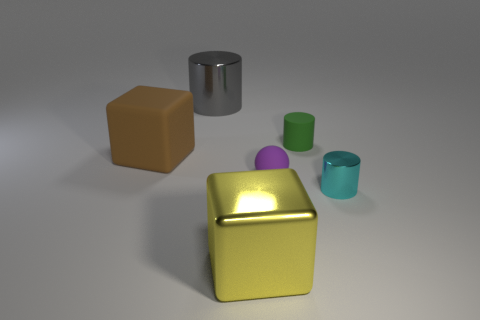Add 2 shiny blocks. How many objects exist? 8 Subtract all tiny shiny cylinders. How many cylinders are left? 2 Subtract all green cylinders. How many cylinders are left? 2 Subtract all green spheres. How many yellow cubes are left? 1 Subtract all cubes. How many objects are left? 4 Subtract 1 spheres. How many spheres are left? 0 Subtract all gray blocks. Subtract all cyan spheres. How many blocks are left? 2 Subtract all green matte cylinders. Subtract all tiny cyan cylinders. How many objects are left? 4 Add 6 purple rubber things. How many purple rubber things are left? 7 Add 2 purple shiny cubes. How many purple shiny cubes exist? 2 